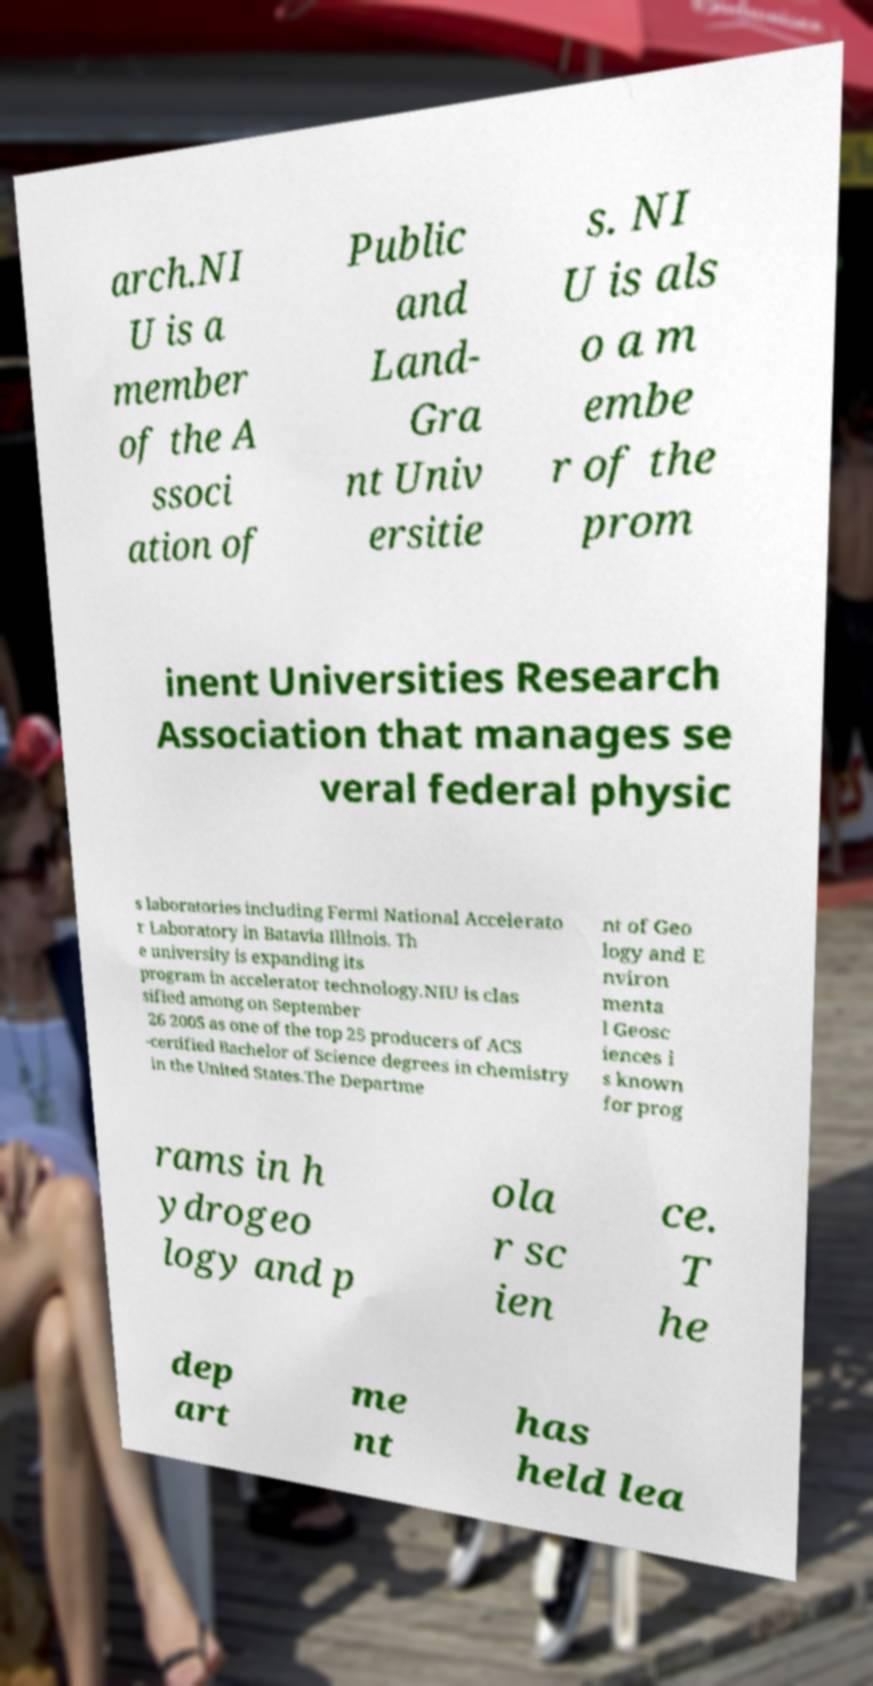Please read and relay the text visible in this image. What does it say? arch.NI U is a member of the A ssoci ation of Public and Land- Gra nt Univ ersitie s. NI U is als o a m embe r of the prom inent Universities Research Association that manages se veral federal physic s laboratories including Fermi National Accelerato r Laboratory in Batavia Illinois. Th e university is expanding its program in accelerator technology.NIU is clas sified among on September 26 2005 as one of the top 25 producers of ACS -certified Bachelor of Science degrees in chemistry in the United States.The Departme nt of Geo logy and E nviron menta l Geosc iences i s known for prog rams in h ydrogeo logy and p ola r sc ien ce. T he dep art me nt has held lea 